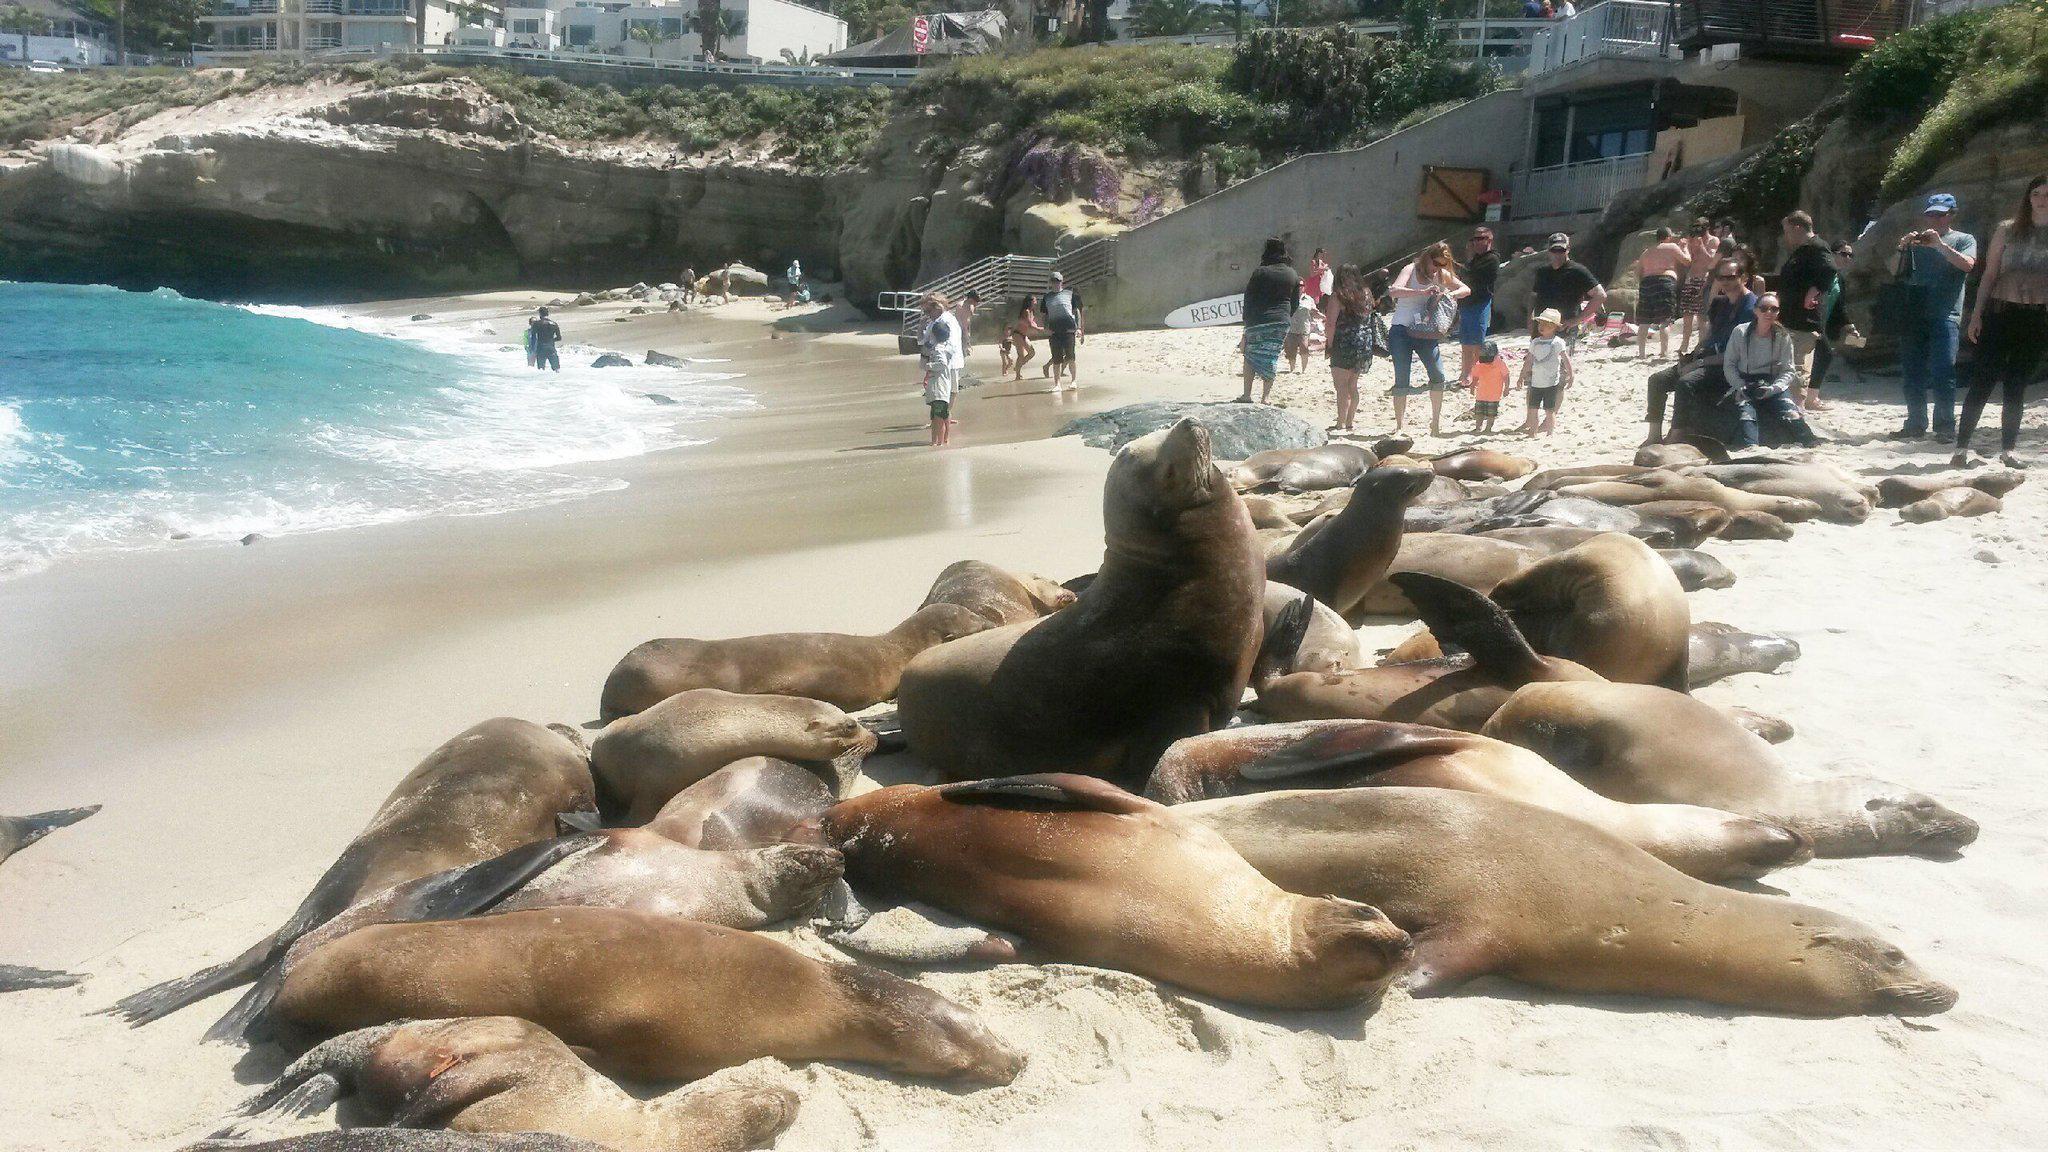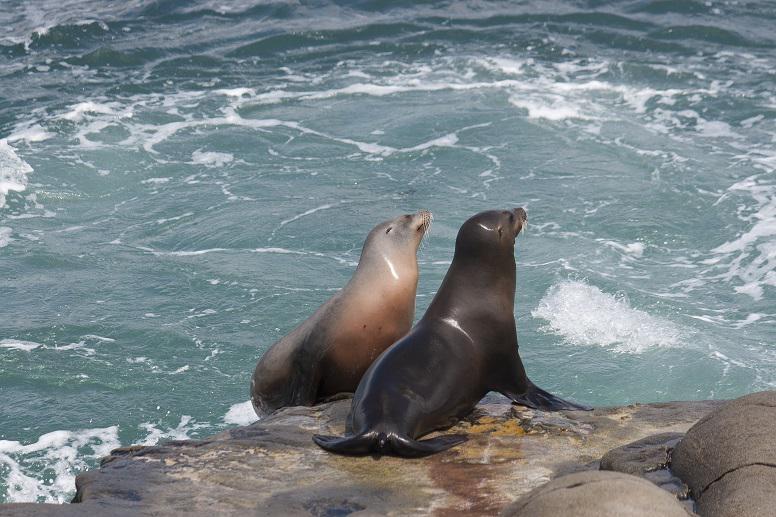The first image is the image on the left, the second image is the image on the right. For the images displayed, is the sentence "There is at least one image where the sea lions are lying in the sand." factually correct? Answer yes or no. Yes. The first image is the image on the left, the second image is the image on the right. Considering the images on both sides, is "There are two sea lions in one of the images." valid? Answer yes or no. Yes. 